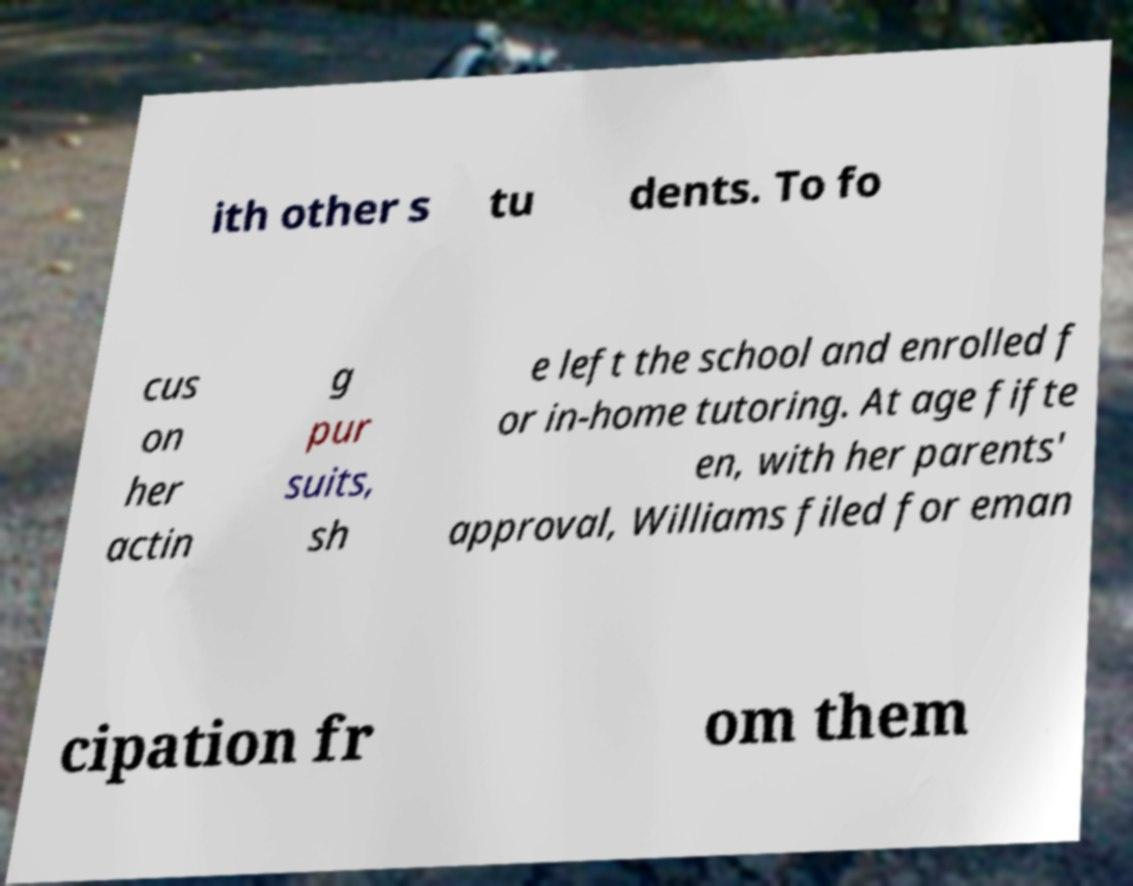Could you extract and type out the text from this image? ith other s tu dents. To fo cus on her actin g pur suits, sh e left the school and enrolled f or in-home tutoring. At age fifte en, with her parents' approval, Williams filed for eman cipation fr om them 